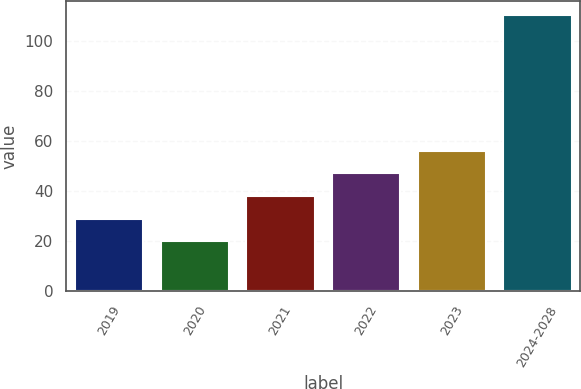Convert chart. <chart><loc_0><loc_0><loc_500><loc_500><bar_chart><fcel>2019<fcel>2020<fcel>2021<fcel>2022<fcel>2023<fcel>2024-2028<nl><fcel>28.89<fcel>19.8<fcel>37.98<fcel>47.07<fcel>56.16<fcel>110.7<nl></chart> 